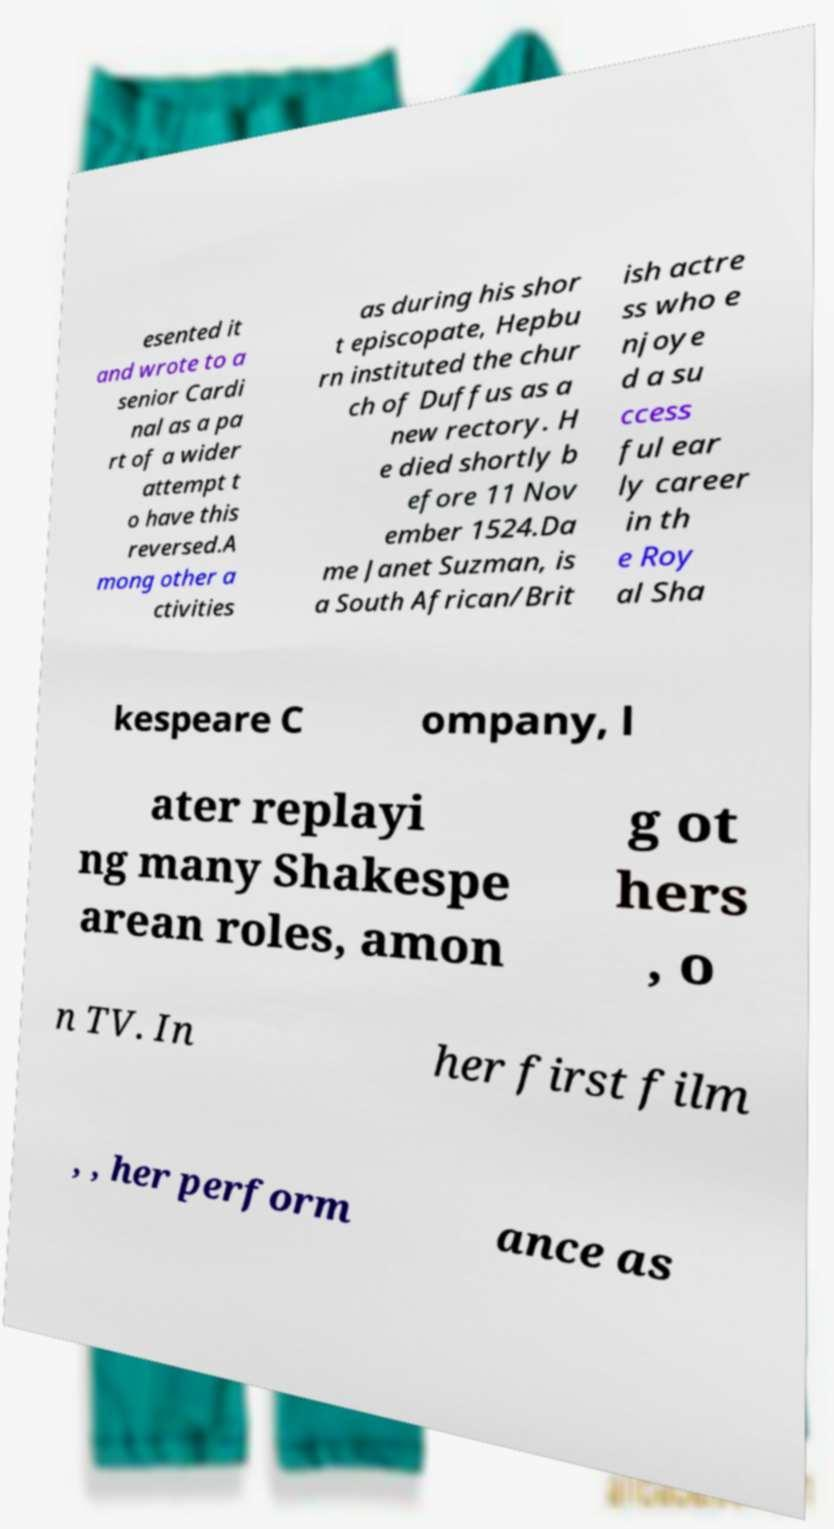I need the written content from this picture converted into text. Can you do that? esented it and wrote to a senior Cardi nal as a pa rt of a wider attempt t o have this reversed.A mong other a ctivities as during his shor t episcopate, Hepbu rn instituted the chur ch of Duffus as a new rectory. H e died shortly b efore 11 Nov ember 1524.Da me Janet Suzman, is a South African/Brit ish actre ss who e njoye d a su ccess ful ear ly career in th e Roy al Sha kespeare C ompany, l ater replayi ng many Shakespe arean roles, amon g ot hers , o n TV. In her first film , , her perform ance as 